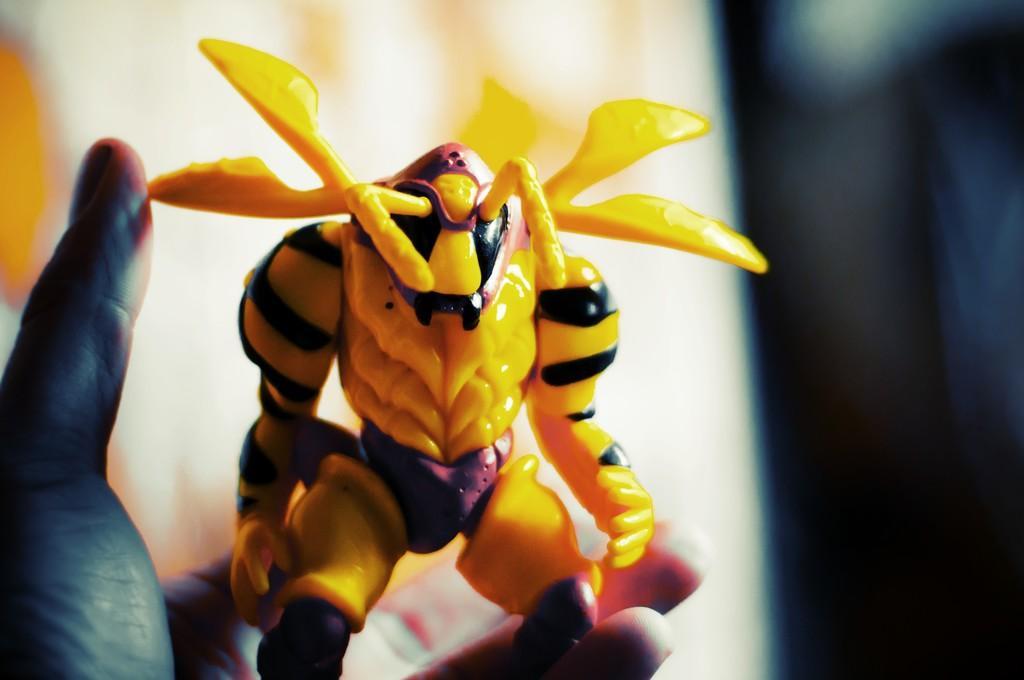Could you give a brief overview of what you see in this image? In this image I can see a person is holding a toy in hand. In the background I can see lights, white color and dark color. This image is taken, may be in a room. 